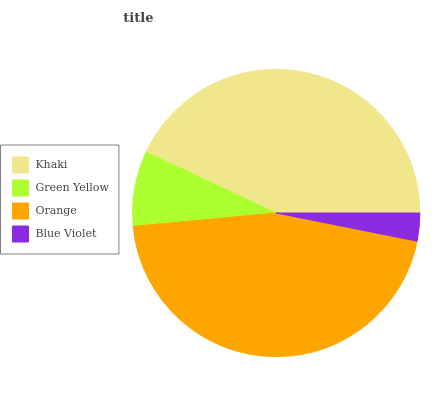Is Blue Violet the minimum?
Answer yes or no. Yes. Is Orange the maximum?
Answer yes or no. Yes. Is Green Yellow the minimum?
Answer yes or no. No. Is Green Yellow the maximum?
Answer yes or no. No. Is Khaki greater than Green Yellow?
Answer yes or no. Yes. Is Green Yellow less than Khaki?
Answer yes or no. Yes. Is Green Yellow greater than Khaki?
Answer yes or no. No. Is Khaki less than Green Yellow?
Answer yes or no. No. Is Khaki the high median?
Answer yes or no. Yes. Is Green Yellow the low median?
Answer yes or no. Yes. Is Orange the high median?
Answer yes or no. No. Is Orange the low median?
Answer yes or no. No. 